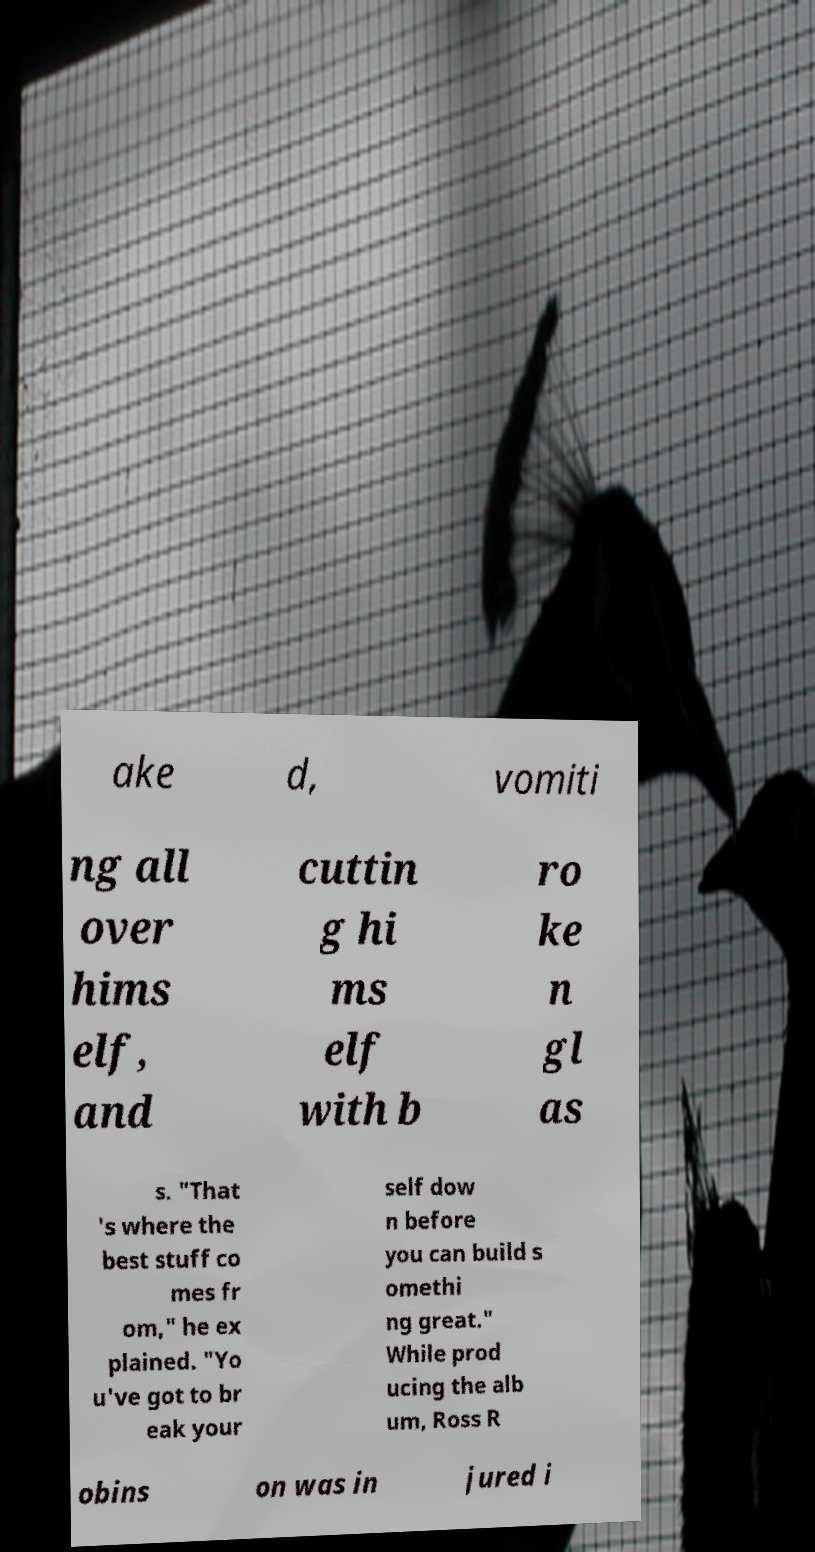Please identify and transcribe the text found in this image. ake d, vomiti ng all over hims elf, and cuttin g hi ms elf with b ro ke n gl as s. "That 's where the best stuff co mes fr om," he ex plained. "Yo u've got to br eak your self dow n before you can build s omethi ng great." While prod ucing the alb um, Ross R obins on was in jured i 